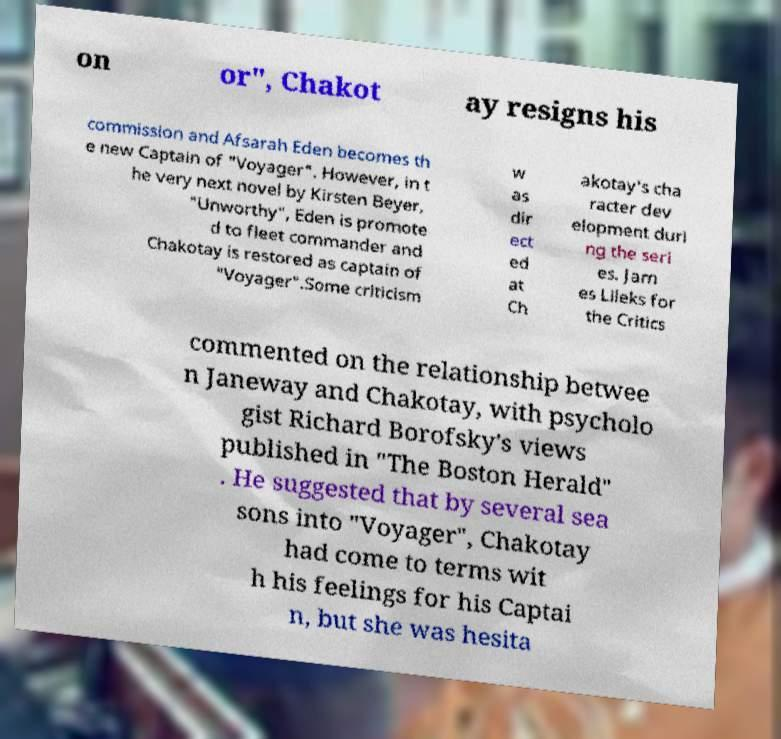Can you accurately transcribe the text from the provided image for me? on or", Chakot ay resigns his commission and Afsarah Eden becomes th e new Captain of "Voyager". However, in t he very next novel by Kirsten Beyer, "Unworthy", Eden is promote d to fleet commander and Chakotay is restored as captain of "Voyager".Some criticism w as dir ect ed at Ch akotay's cha racter dev elopment duri ng the seri es. Jam es Lileks for the Critics commented on the relationship betwee n Janeway and Chakotay, with psycholo gist Richard Borofsky's views published in "The Boston Herald" . He suggested that by several sea sons into "Voyager", Chakotay had come to terms wit h his feelings for his Captai n, but she was hesita 